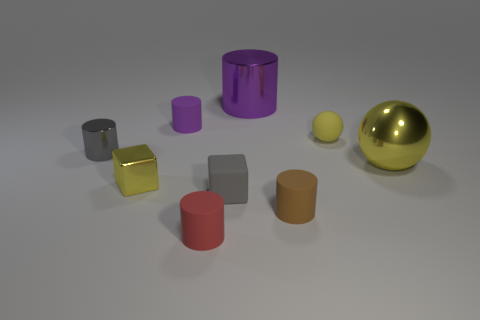The other cylinder that is the same color as the big metal cylinder is what size?
Your answer should be very brief. Small. Does the small rubber thing in front of the brown matte cylinder have the same shape as the big object in front of the small gray metal cylinder?
Your answer should be very brief. No. What number of objects are large brown metal balls or small rubber balls?
Your answer should be compact. 1. Is there any other thing that has the same material as the small purple cylinder?
Your answer should be very brief. Yes. Is there a blue thing?
Your response must be concise. No. Do the purple cylinder that is right of the gray cube and the tiny red object have the same material?
Ensure brevity in your answer.  No. Is there a brown object that has the same shape as the large yellow metal object?
Make the answer very short. No. Is the number of tiny yellow balls left of the brown cylinder the same as the number of yellow matte objects?
Your answer should be compact. No. What material is the tiny gray thing that is to the left of the tiny yellow object that is to the left of the small red matte object?
Provide a succinct answer. Metal. What is the shape of the small purple thing?
Your answer should be compact. Cylinder. 